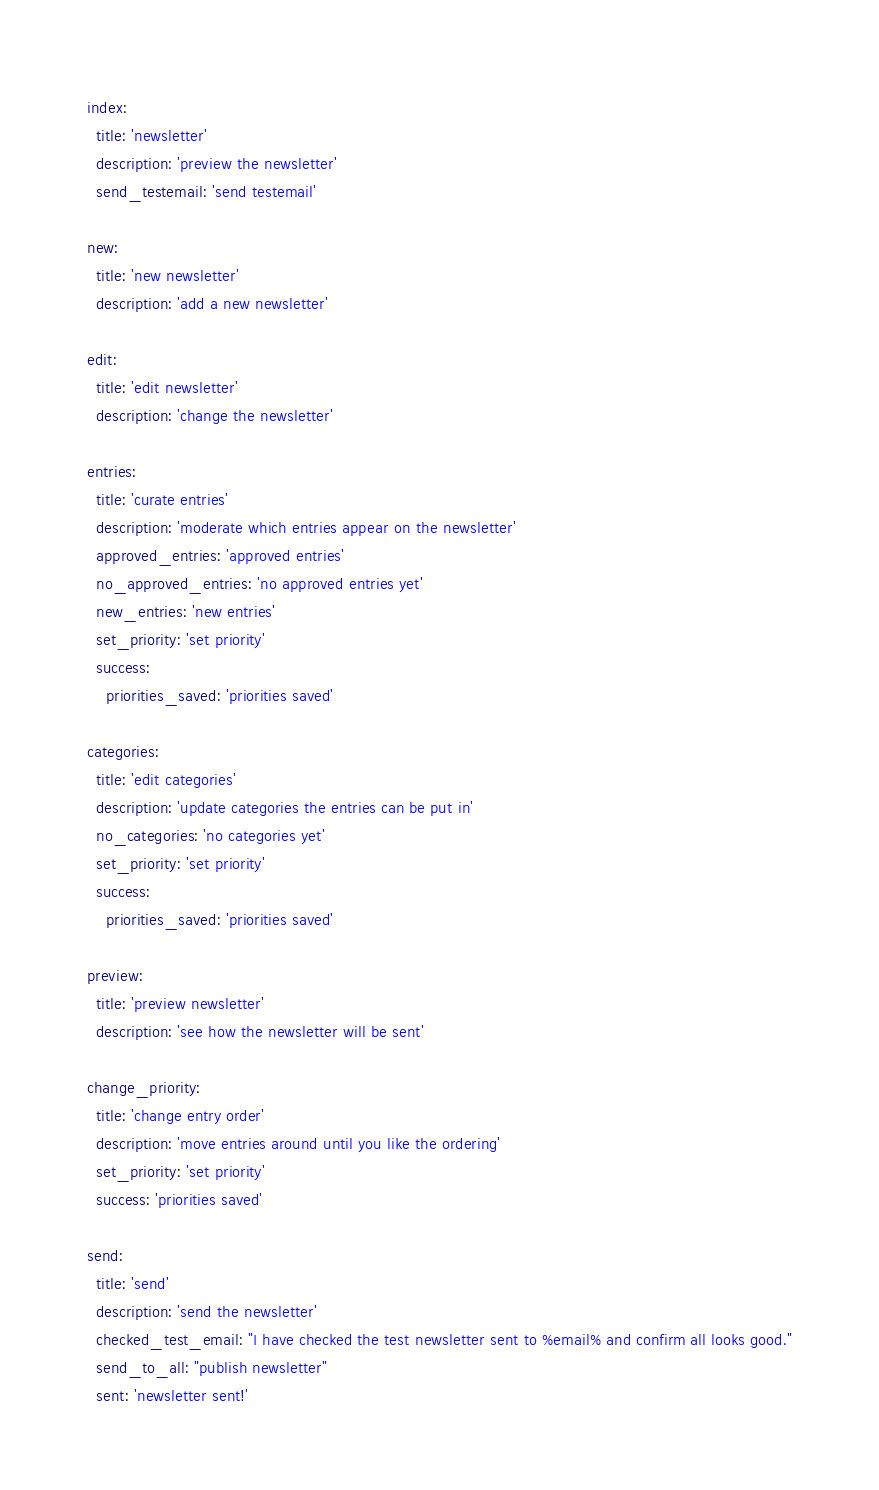<code> <loc_0><loc_0><loc_500><loc_500><_YAML_>index:
  title: 'newsletter'
  description: 'preview the newsletter'
  send_testemail: 'send testemail'

new:
  title: 'new newsletter'
  description: 'add a new newsletter'

edit:
  title: 'edit newsletter'
  description: 'change the newsletter'

entries:
  title: 'curate entries'
  description: 'moderate which entries appear on the newsletter'
  approved_entries: 'approved entries'
  no_approved_entries: 'no approved entries yet'
  new_entries: 'new entries'
  set_priority: 'set priority'
  success:
    priorities_saved: 'priorities saved'

categories:
  title: 'edit categories'
  description: 'update categories the entries can be put in'
  no_categories: 'no categories yet'
  set_priority: 'set priority'
  success:
    priorities_saved: 'priorities saved'

preview:
  title: 'preview newsletter'
  description: 'see how the newsletter will be sent'

change_priority:
  title: 'change entry order'
  description: 'move entries around until you like the ordering'
  set_priority: 'set priority'
  success: 'priorities saved'

send:
  title: 'send'
  description: 'send the newsletter'
  checked_test_email: "I have checked the test newsletter sent to %email% and confirm all looks good."
  send_to_all: "publish newsletter"
  sent: 'newsletter sent!'
</code> 